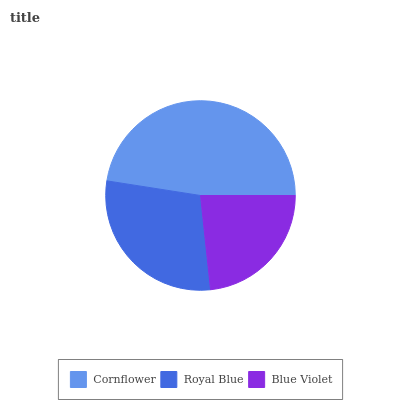Is Blue Violet the minimum?
Answer yes or no. Yes. Is Cornflower the maximum?
Answer yes or no. Yes. Is Royal Blue the minimum?
Answer yes or no. No. Is Royal Blue the maximum?
Answer yes or no. No. Is Cornflower greater than Royal Blue?
Answer yes or no. Yes. Is Royal Blue less than Cornflower?
Answer yes or no. Yes. Is Royal Blue greater than Cornflower?
Answer yes or no. No. Is Cornflower less than Royal Blue?
Answer yes or no. No. Is Royal Blue the high median?
Answer yes or no. Yes. Is Royal Blue the low median?
Answer yes or no. Yes. Is Blue Violet the high median?
Answer yes or no. No. Is Cornflower the low median?
Answer yes or no. No. 